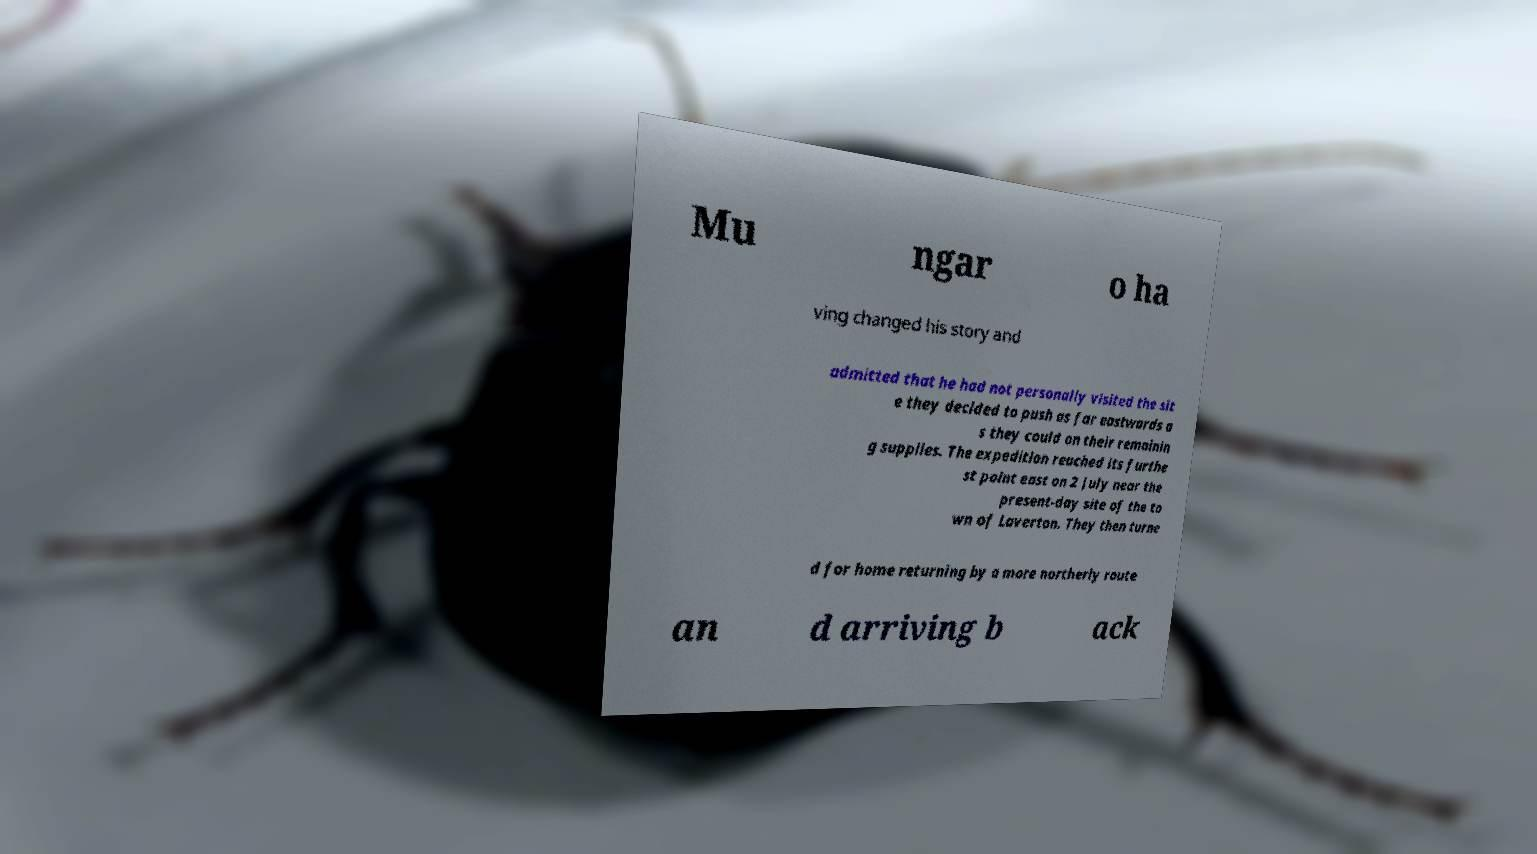For documentation purposes, I need the text within this image transcribed. Could you provide that? Mu ngar o ha ving changed his story and admitted that he had not personally visited the sit e they decided to push as far eastwards a s they could on their remainin g supplies. The expedition reached its furthe st point east on 2 July near the present-day site of the to wn of Laverton. They then turne d for home returning by a more northerly route an d arriving b ack 